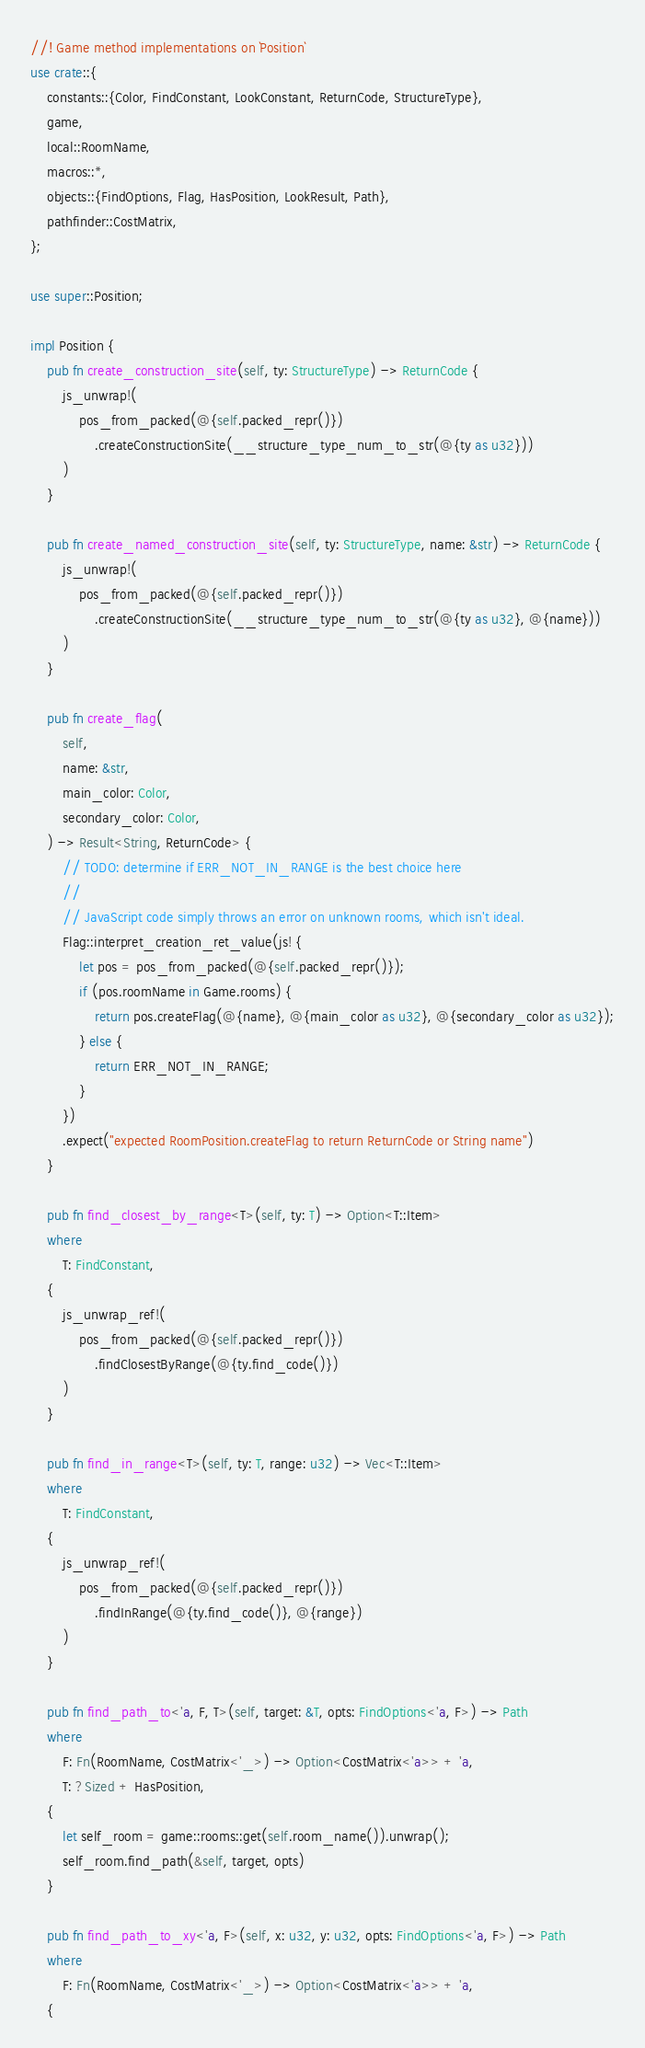Convert code to text. <code><loc_0><loc_0><loc_500><loc_500><_Rust_>//! Game method implementations on `Position`
use crate::{
    constants::{Color, FindConstant, LookConstant, ReturnCode, StructureType},
    game,
    local::RoomName,
    macros::*,
    objects::{FindOptions, Flag, HasPosition, LookResult, Path},
    pathfinder::CostMatrix,
};

use super::Position;

impl Position {
    pub fn create_construction_site(self, ty: StructureType) -> ReturnCode {
        js_unwrap!(
            pos_from_packed(@{self.packed_repr()})
                .createConstructionSite(__structure_type_num_to_str(@{ty as u32}))
        )
    }

    pub fn create_named_construction_site(self, ty: StructureType, name: &str) -> ReturnCode {
        js_unwrap!(
            pos_from_packed(@{self.packed_repr()})
                .createConstructionSite(__structure_type_num_to_str(@{ty as u32}, @{name}))
        )
    }

    pub fn create_flag(
        self,
        name: &str,
        main_color: Color,
        secondary_color: Color,
    ) -> Result<String, ReturnCode> {
        // TODO: determine if ERR_NOT_IN_RANGE is the best choice here
        //
        // JavaScript code simply throws an error on unknown rooms, which isn't ideal.
        Flag::interpret_creation_ret_value(js! {
            let pos = pos_from_packed(@{self.packed_repr()});
            if (pos.roomName in Game.rooms) {
                return pos.createFlag(@{name}, @{main_color as u32}, @{secondary_color as u32});
            } else {
                return ERR_NOT_IN_RANGE;
            }
        })
        .expect("expected RoomPosition.createFlag to return ReturnCode or String name")
    }

    pub fn find_closest_by_range<T>(self, ty: T) -> Option<T::Item>
    where
        T: FindConstant,
    {
        js_unwrap_ref!(
            pos_from_packed(@{self.packed_repr()})
                .findClosestByRange(@{ty.find_code()})
        )
    }

    pub fn find_in_range<T>(self, ty: T, range: u32) -> Vec<T::Item>
    where
        T: FindConstant,
    {
        js_unwrap_ref!(
            pos_from_packed(@{self.packed_repr()})
                .findInRange(@{ty.find_code()}, @{range})
        )
    }

    pub fn find_path_to<'a, F, T>(self, target: &T, opts: FindOptions<'a, F>) -> Path
    where
        F: Fn(RoomName, CostMatrix<'_>) -> Option<CostMatrix<'a>> + 'a,
        T: ?Sized + HasPosition,
    {
        let self_room = game::rooms::get(self.room_name()).unwrap();
        self_room.find_path(&self, target, opts)
    }

    pub fn find_path_to_xy<'a, F>(self, x: u32, y: u32, opts: FindOptions<'a, F>) -> Path
    where
        F: Fn(RoomName, CostMatrix<'_>) -> Option<CostMatrix<'a>> + 'a,
    {</code> 